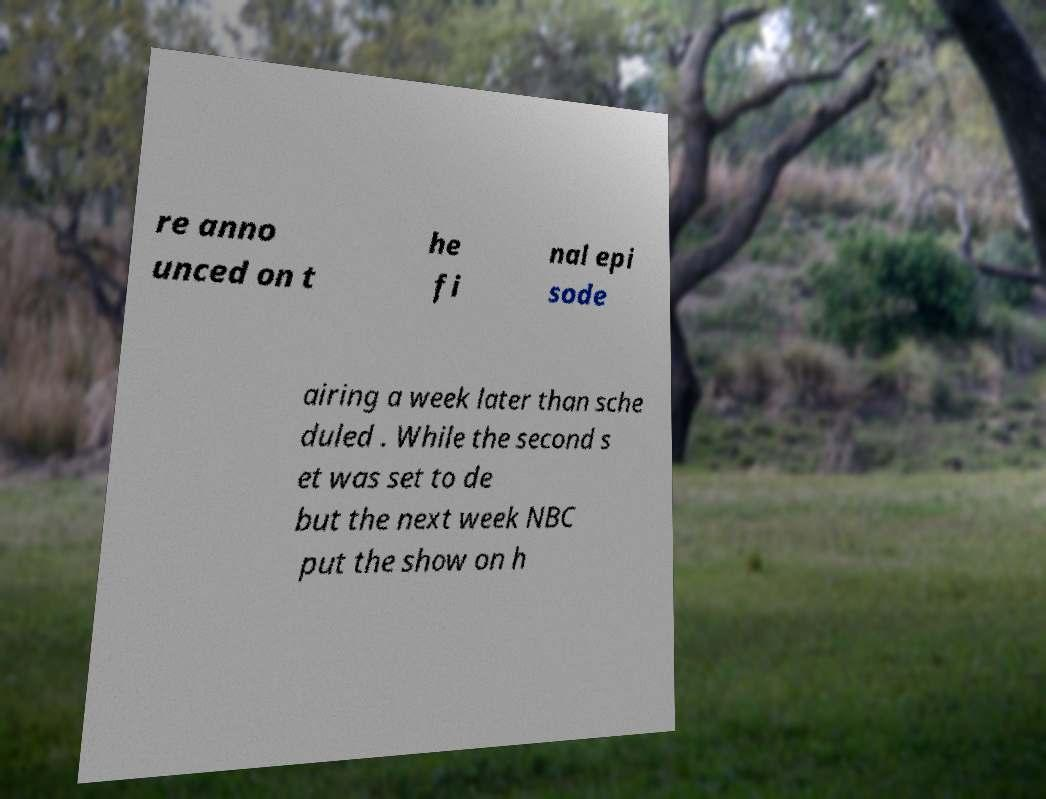I need the written content from this picture converted into text. Can you do that? re anno unced on t he fi nal epi sode airing a week later than sche duled . While the second s et was set to de but the next week NBC put the show on h 